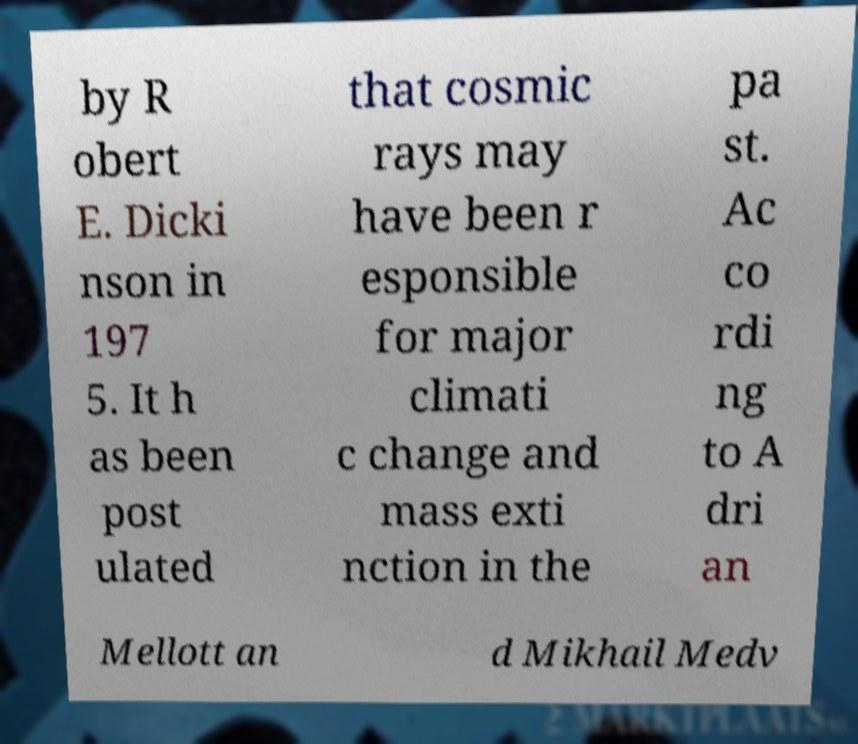Can you read and provide the text displayed in the image?This photo seems to have some interesting text. Can you extract and type it out for me? by R obert E. Dicki nson in 197 5. It h as been post ulated that cosmic rays may have been r esponsible for major climati c change and mass exti nction in the pa st. Ac co rdi ng to A dri an Mellott an d Mikhail Medv 